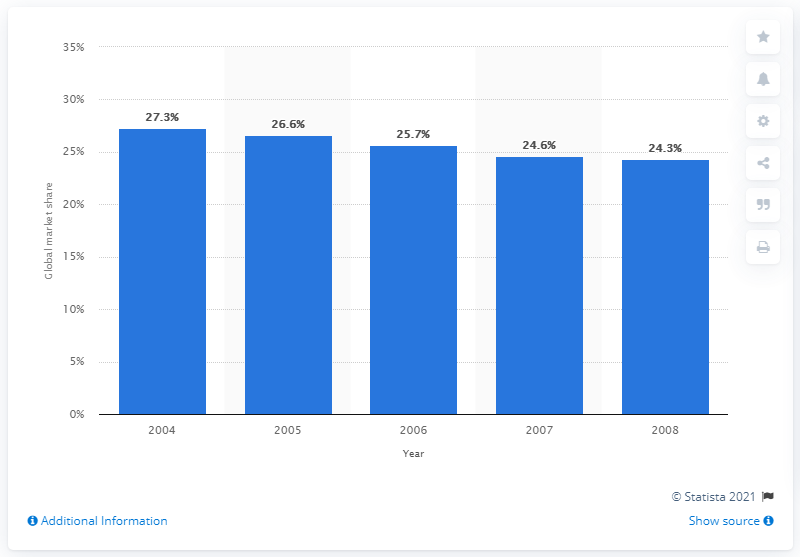Outline some significant characteristics in this image. In 2007, the global market share of the U.S. athletic and non-athletic footwear retail market was 24.6%. 